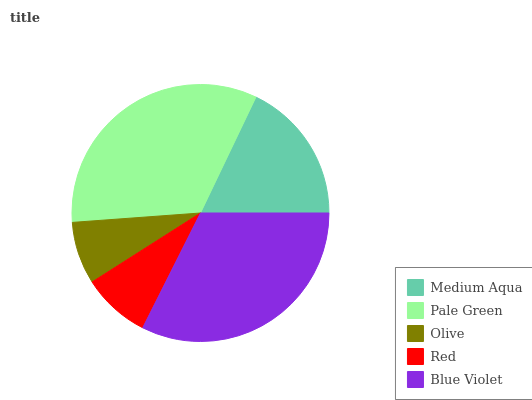Is Olive the minimum?
Answer yes or no. Yes. Is Pale Green the maximum?
Answer yes or no. Yes. Is Pale Green the minimum?
Answer yes or no. No. Is Olive the maximum?
Answer yes or no. No. Is Pale Green greater than Olive?
Answer yes or no. Yes. Is Olive less than Pale Green?
Answer yes or no. Yes. Is Olive greater than Pale Green?
Answer yes or no. No. Is Pale Green less than Olive?
Answer yes or no. No. Is Medium Aqua the high median?
Answer yes or no. Yes. Is Medium Aqua the low median?
Answer yes or no. Yes. Is Olive the high median?
Answer yes or no. No. Is Blue Violet the low median?
Answer yes or no. No. 